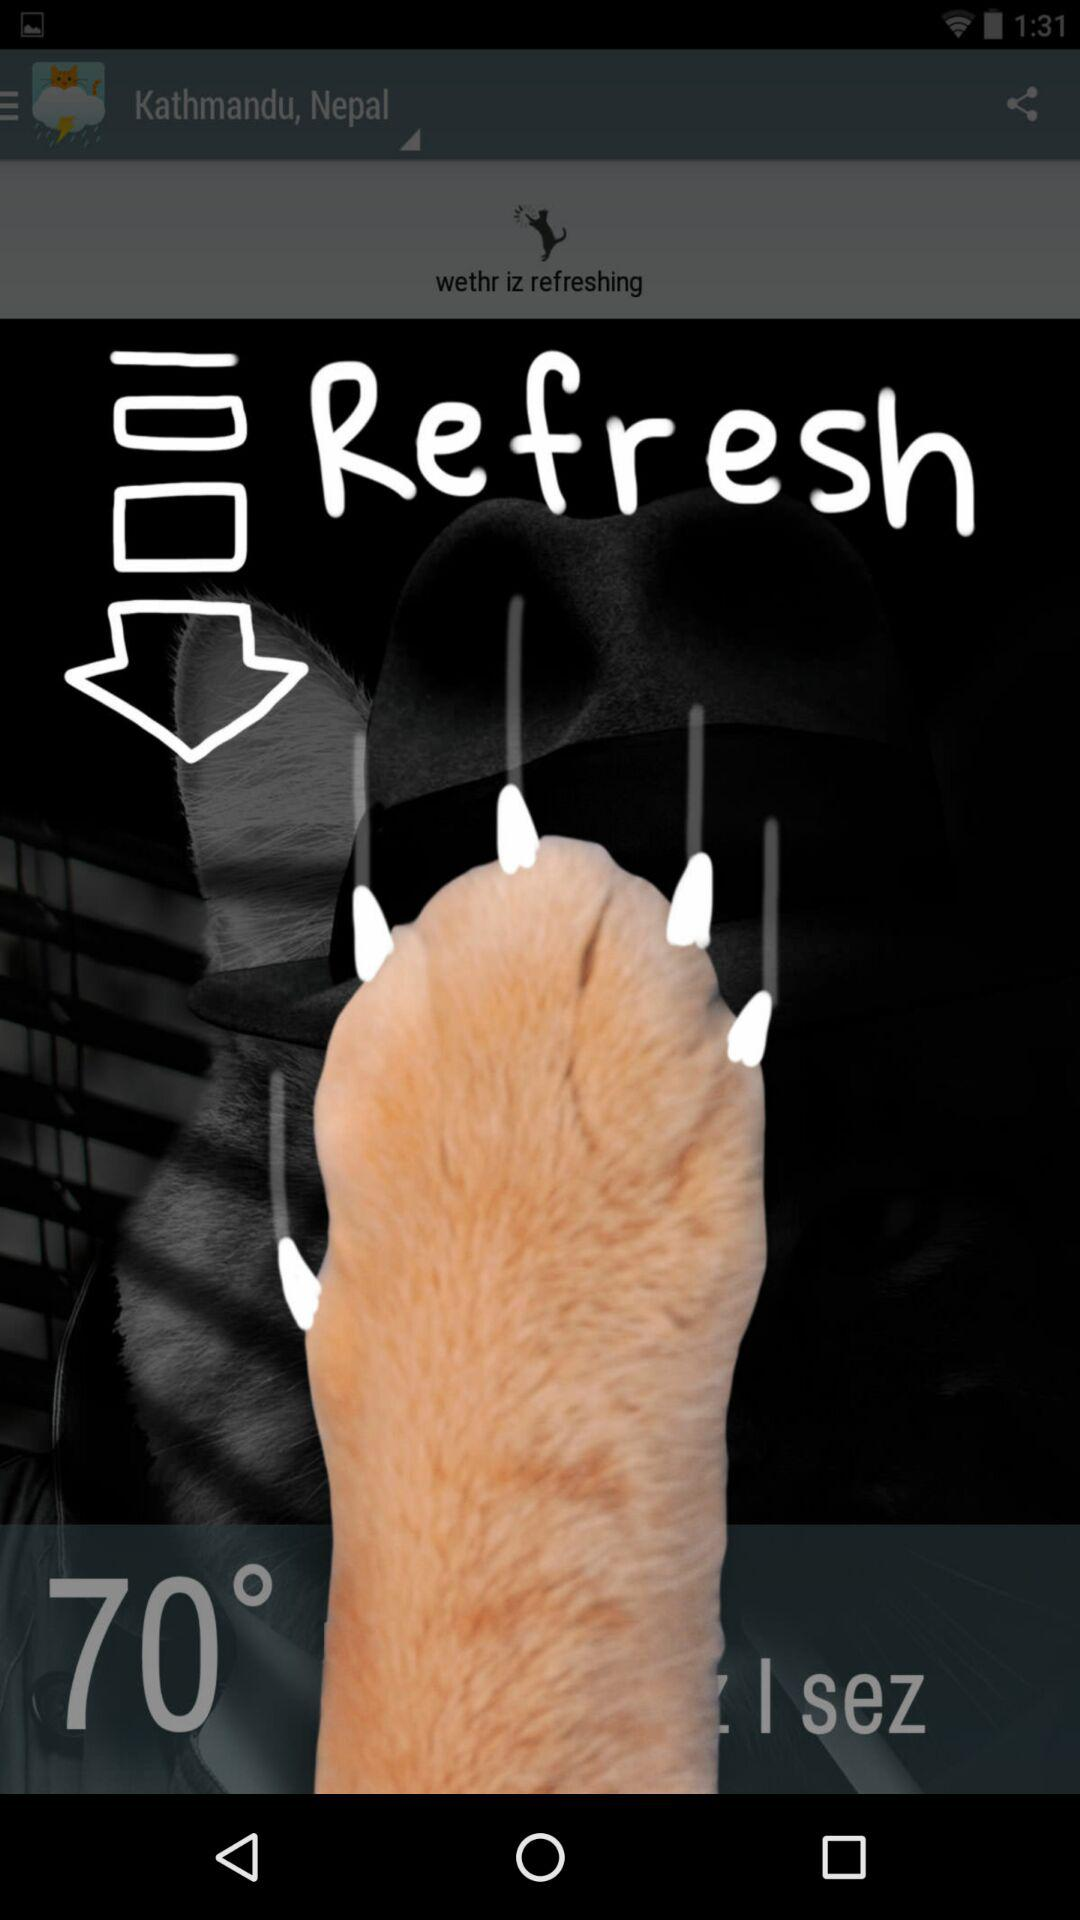What location is shown? The shown location is Kathmandu, Nepal. 